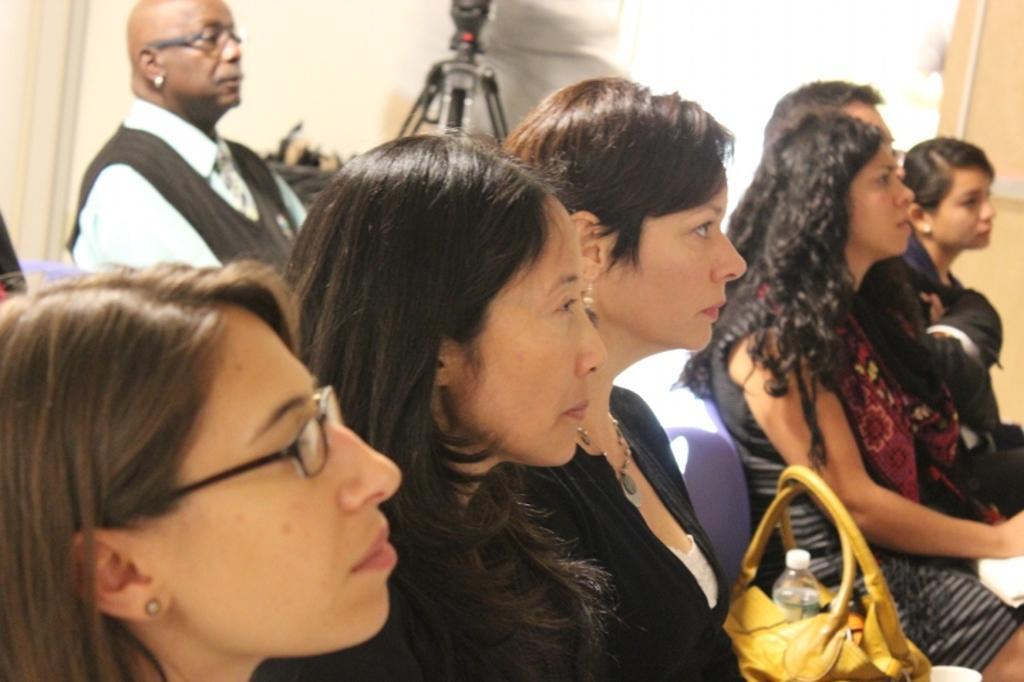Could you give a brief overview of what you see in this image? In the image there are few ladies sitting on chairs in the front, in the back there is a man sitting and behind him there is a tripod in front of the wall. 